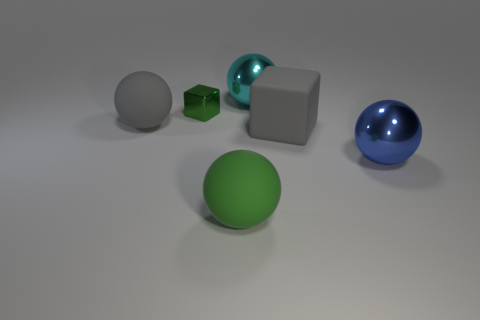Subtract all green balls. How many balls are left? 3 Add 4 big cyan things. How many objects exist? 10 Subtract 2 spheres. How many spheres are left? 2 Subtract all gray balls. How many balls are left? 3 Subtract 0 red cylinders. How many objects are left? 6 Subtract all cubes. How many objects are left? 4 Subtract all cyan blocks. Subtract all yellow cylinders. How many blocks are left? 2 Subtract all red cylinders. How many blue spheres are left? 1 Subtract all spheres. Subtract all gray things. How many objects are left? 0 Add 5 large rubber balls. How many large rubber balls are left? 7 